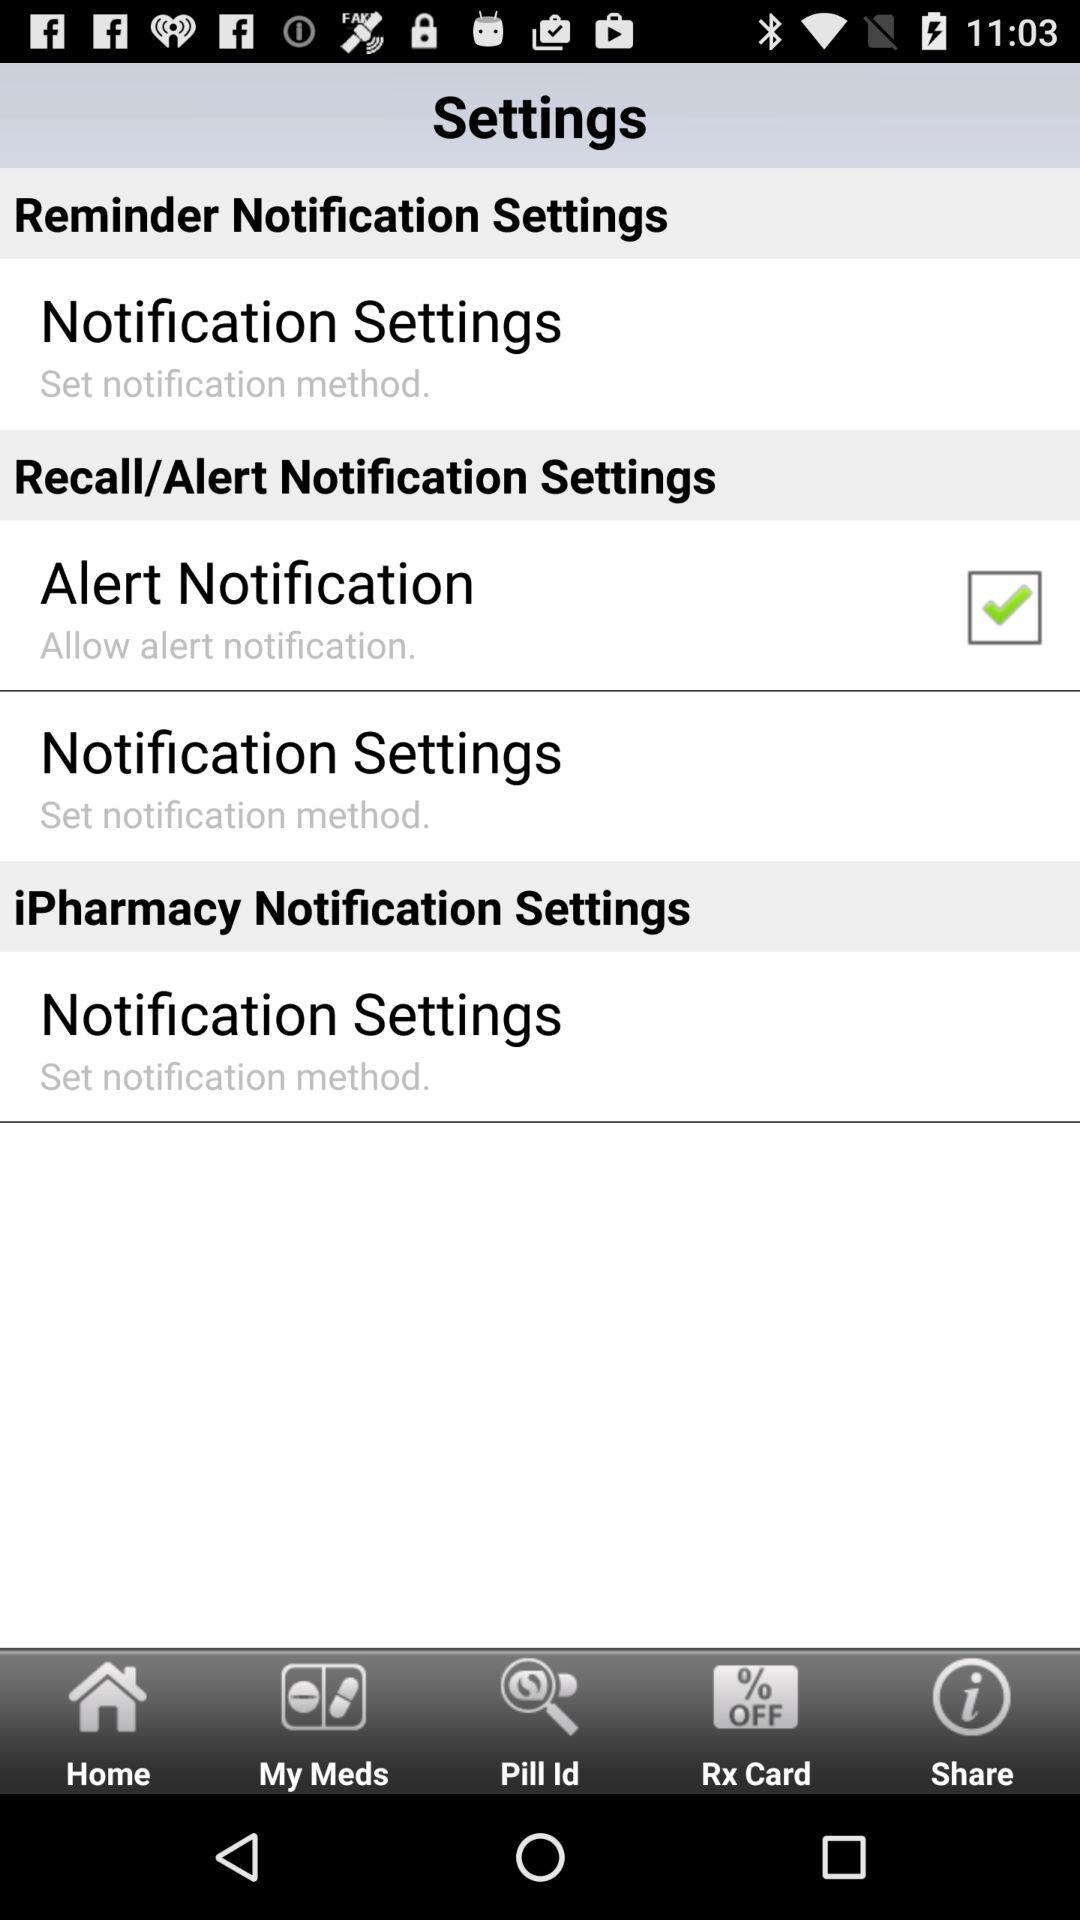What is the status of the alert notification? The status is on. 